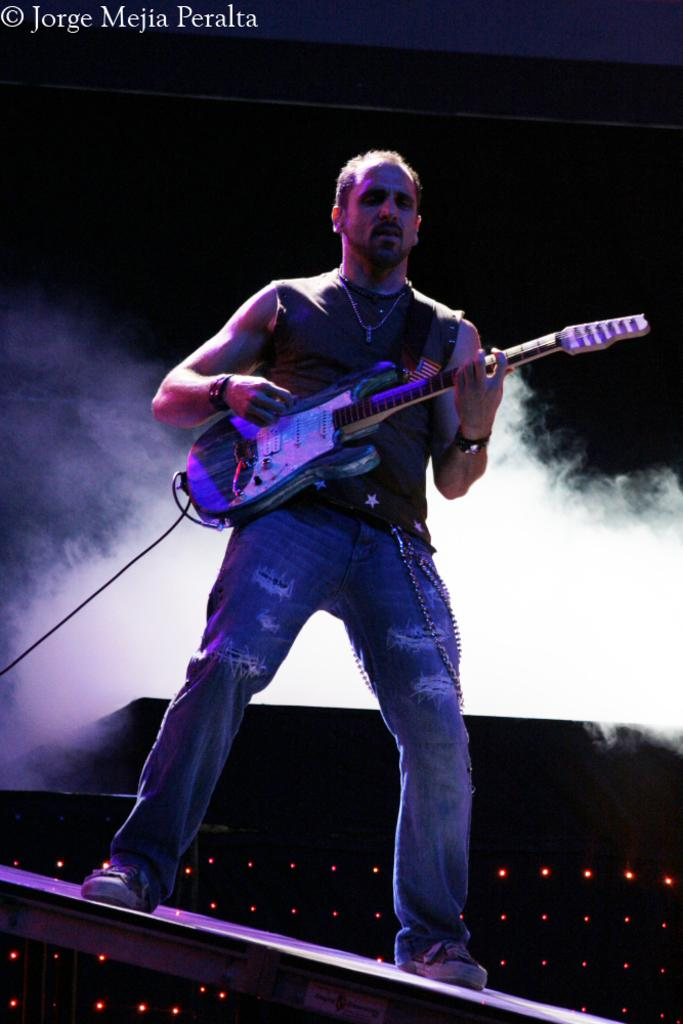What is the main subject of the image? The main subject of the image is a man. What is the man doing in the image? The man is standing and playing the guitar. What type of clothing is the man wearing? The man is wearing a t-shirt and jeans pant. What can be seen in the background of the image? There is foggy smoke in the background of the image. What type of reward is the man holding in the image? There is no reward visible in the image. --- Facts: 1. There is a car in the image. 2. The car is red. 3. The car has four doors. 4. The car has a sunroof. 5. The car is parked on the street. Absurd Topics: unicorn, rainbow, magic Conversation: What is the main subject in the image? The main subject in the image is a car. What color is the car in the image? The car is red in the image. How many doors does the car have in the image? The car has four doors in the image. What special feature does the car have in the image? The car has a sunroof in the image. Where is the car located in the image? The car is parked on the street in the image. Reasoning: Let's think step by step in order to produce the conversation. We start by identifying the main subject of the image, which is the car. Next, we describe specific features of the car, such as its color, the number of doors, and any special features. Then, we observe the location of the car in the image. Finally, we ensure that the language is simple and clear. Absurd Question/Answer: Can you see a unicorn in the image? There is no unicorn visible in the image. --- Facts: 1. There is a group of people in the image. 2. The group of people is standing in a circle. 3. The group of people is holding hands. 4. The group of people is wearing matching t-shirts. 5. The group of people is smiling. Absurd Topics: lion, roar Conversation: What is the main subject in the image? The main subject in the image is a group of people. What are the people in the image doing? The group of people is standing in a circle in the image. How are the people in the image connected? The group of people is holding hands in the image. What are the people in the image wearing? The group of people is wearing matching t-shirts in the image. What is the expression on the faces of the people in the image? The group of people is smiling in the image. Reasoning: Let's think 